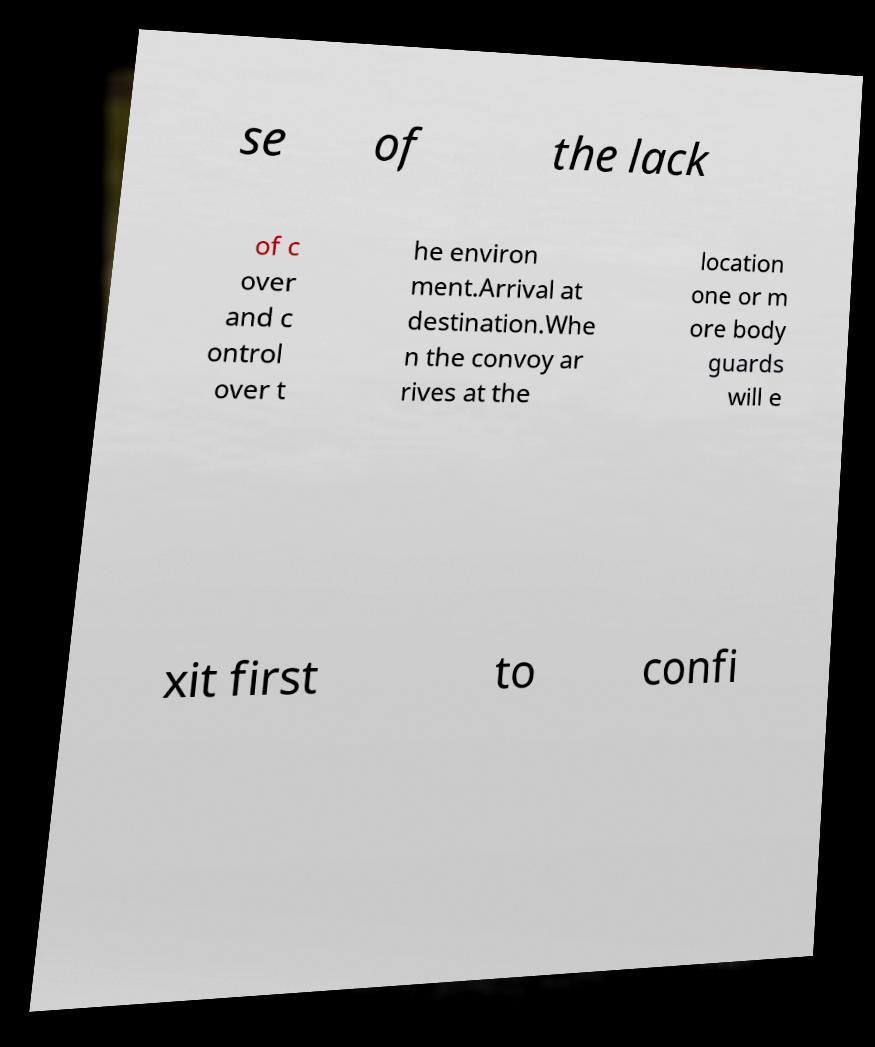Can you accurately transcribe the text from the provided image for me? se of the lack of c over and c ontrol over t he environ ment.Arrival at destination.Whe n the convoy ar rives at the location one or m ore body guards will e xit first to confi 